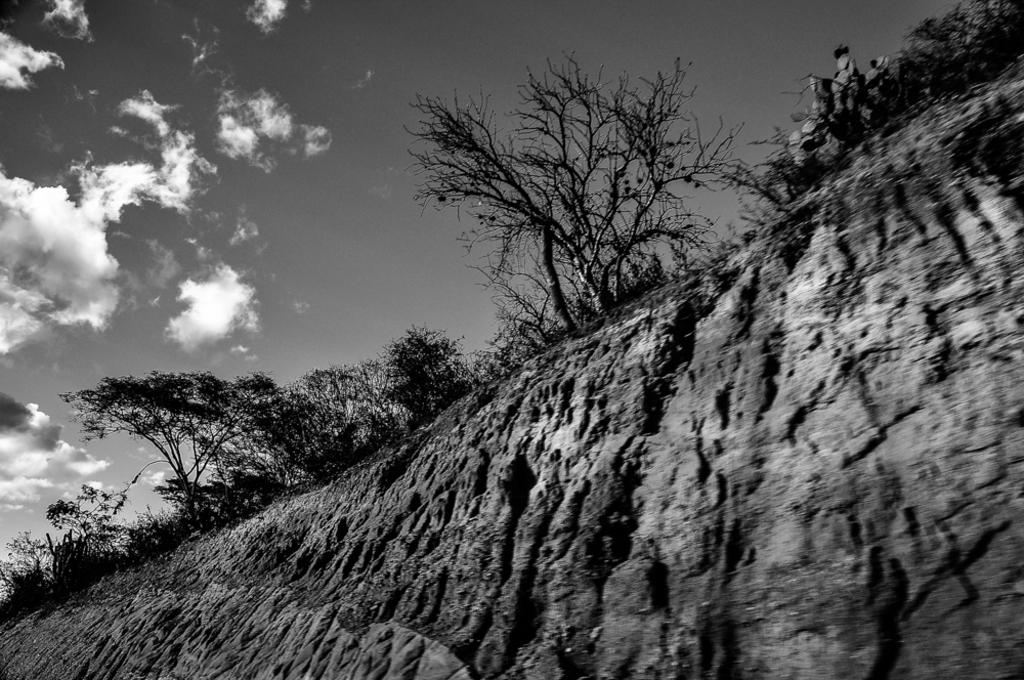What type of natural landform is visible in the image? There is a mountain in the image. What other natural elements can be seen in the image? There are trees and clouds visible in the image. What is the color scheme of the image? The image is in black and white. How many eyes can be seen on the bird in the image? There is no bird present in the image, so it is not possible to determine the number of eyes on a bird. 